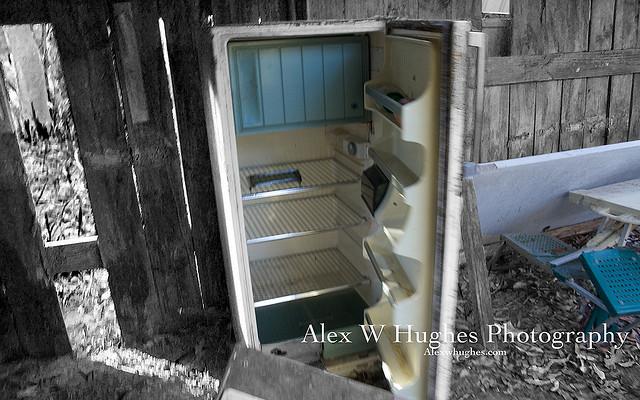Who shot this?
Answer briefly. Alex w hughes. Does the fridge belong where it is?
Write a very short answer. No. Name the type of door open in the picture?
Be succinct. Refrigerator. 